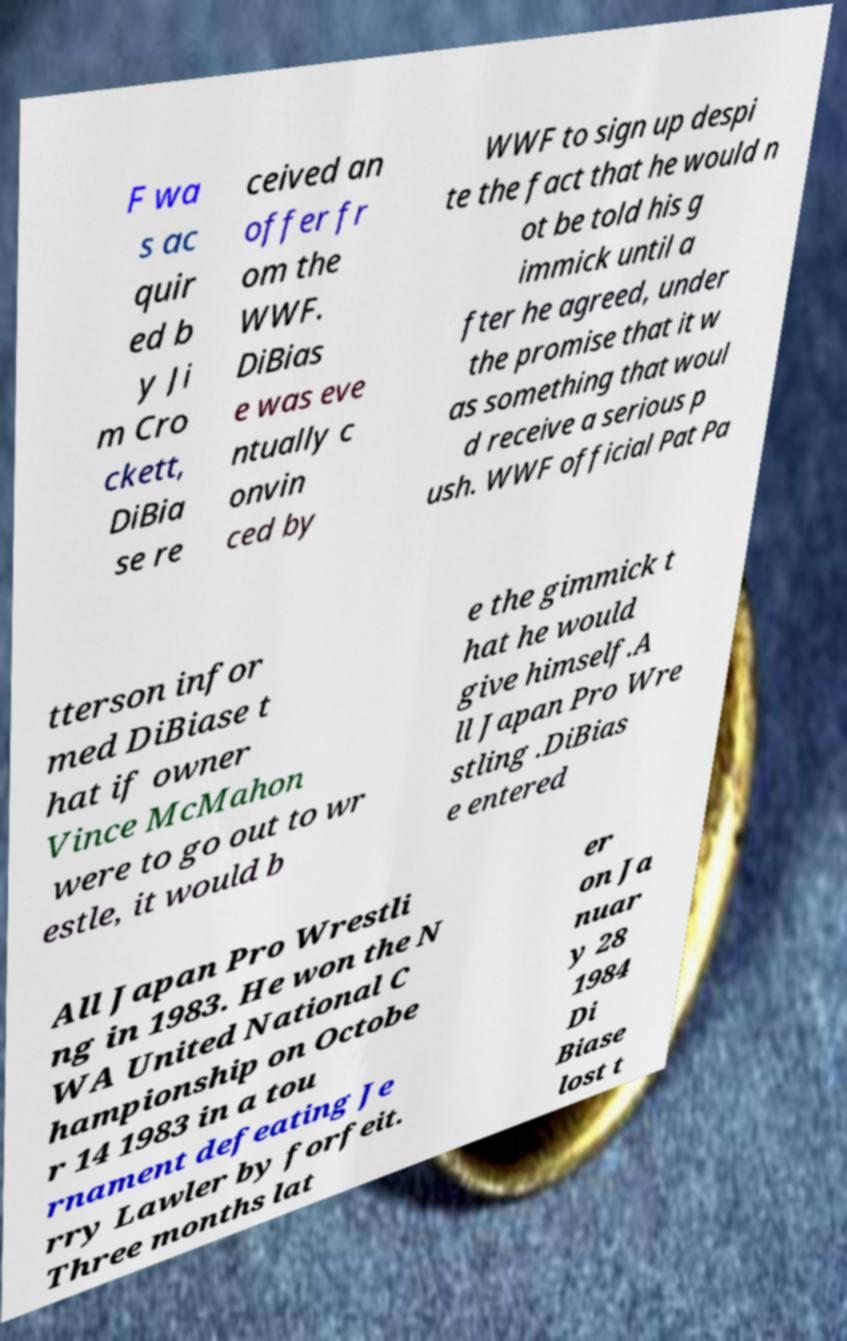Can you read and provide the text displayed in the image?This photo seems to have some interesting text. Can you extract and type it out for me? F wa s ac quir ed b y Ji m Cro ckett, DiBia se re ceived an offer fr om the WWF. DiBias e was eve ntually c onvin ced by WWF to sign up despi te the fact that he would n ot be told his g immick until a fter he agreed, under the promise that it w as something that woul d receive a serious p ush. WWF official Pat Pa tterson infor med DiBiase t hat if owner Vince McMahon were to go out to wr estle, it would b e the gimmick t hat he would give himself.A ll Japan Pro Wre stling .DiBias e entered All Japan Pro Wrestli ng in 1983. He won the N WA United National C hampionship on Octobe r 14 1983 in a tou rnament defeating Je rry Lawler by forfeit. Three months lat er on Ja nuar y 28 1984 Di Biase lost t 